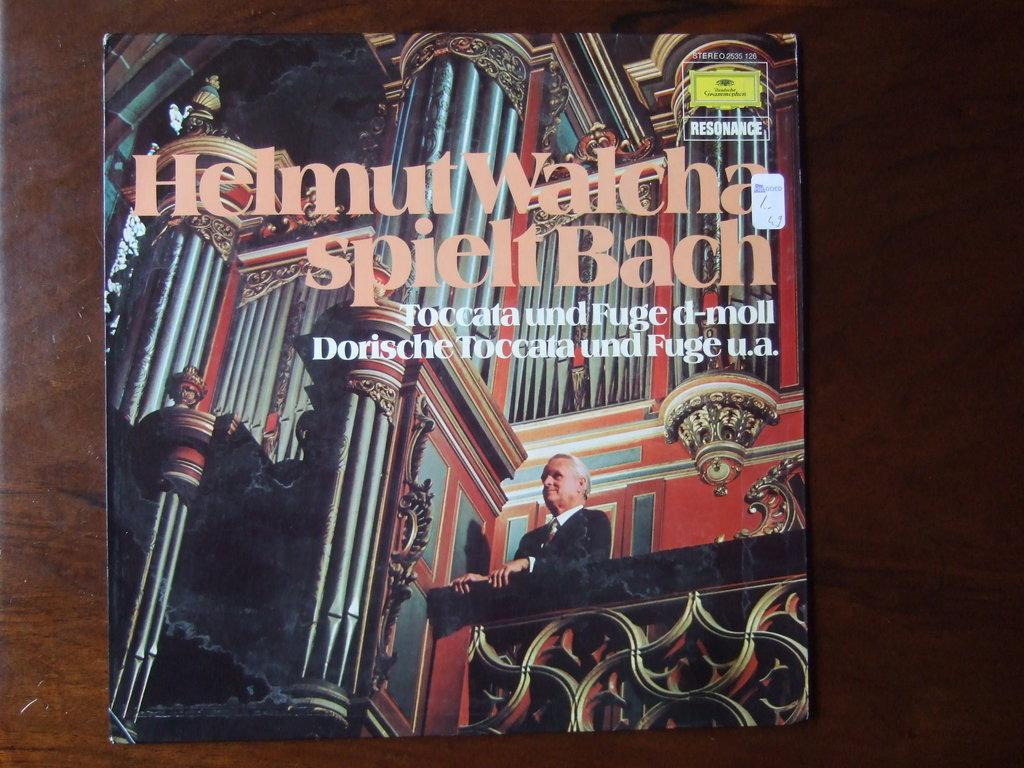<image>
Offer a succinct explanation of the picture presented. The cover of the recurd Helmut Walcha Spielt Back with a man looking over a balcony. 